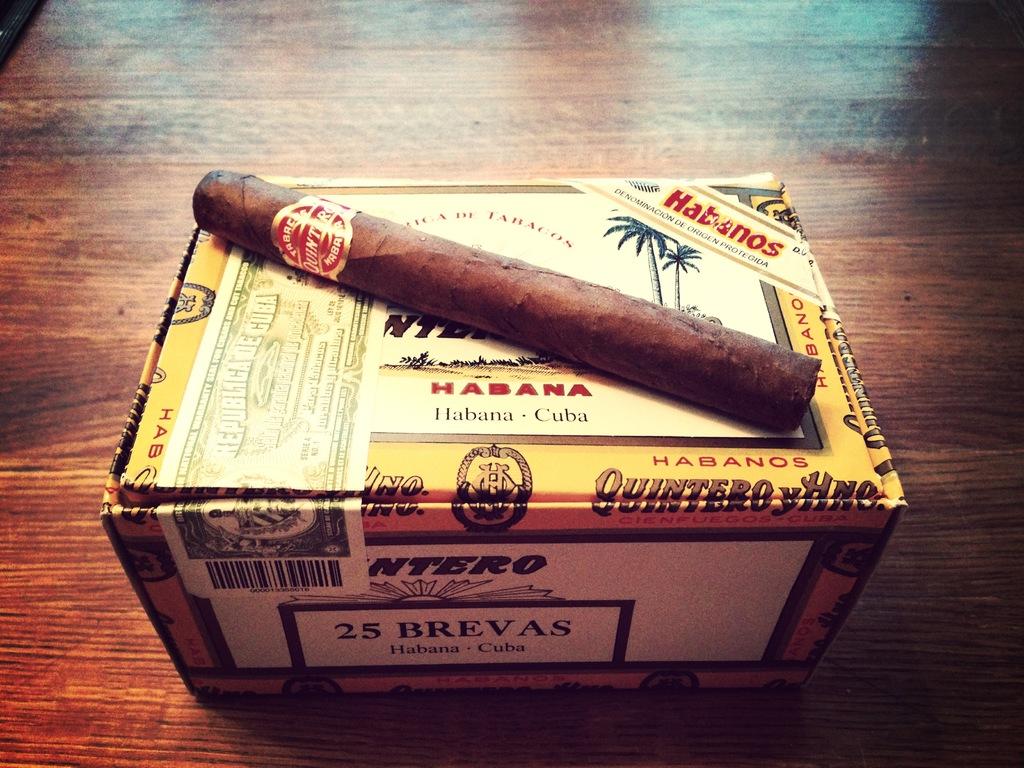Where are the cigars from?
Provide a succinct answer. Cuba. What is the brand?
Keep it short and to the point. Habana. 